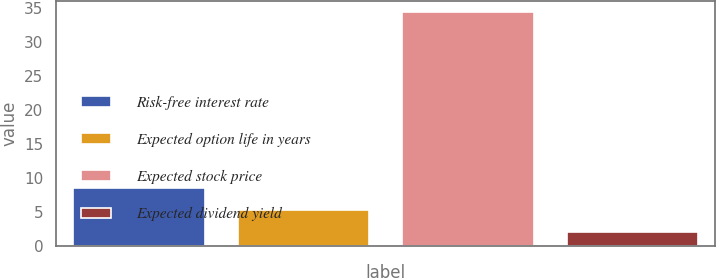Convert chart to OTSL. <chart><loc_0><loc_0><loc_500><loc_500><bar_chart><fcel>Risk-free interest rate<fcel>Expected option life in years<fcel>Expected stock price<fcel>Expected dividend yield<nl><fcel>8.46<fcel>5.23<fcel>34.3<fcel>2<nl></chart> 